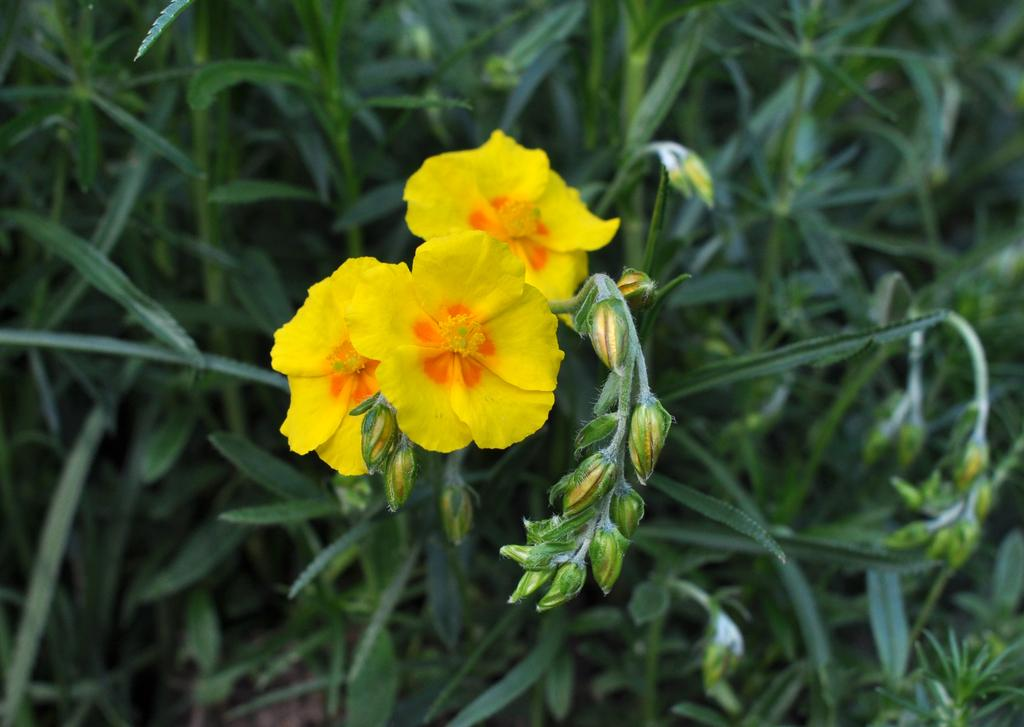What is present in the picture? There is a plant in the picture. What can be observed about the flowers on the plant? The plant has three yellow flowers. Are there any unopened flowers on the plant? Yes, there are buds on the plant. What type of silver structure can be seen in the background of the image? There is no silver structure present in the image; it only features a plant with yellow flowers and buds. 